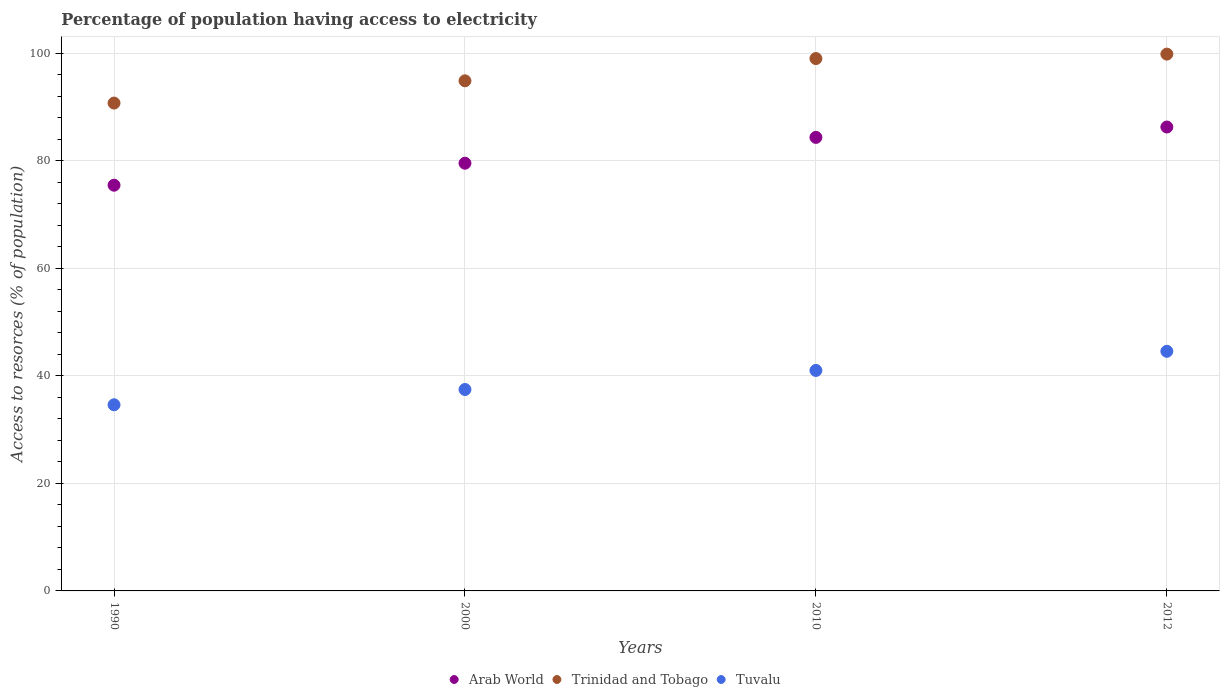How many different coloured dotlines are there?
Your answer should be very brief. 3. What is the percentage of population having access to electricity in Arab World in 2000?
Offer a terse response. 79.54. Across all years, what is the maximum percentage of population having access to electricity in Arab World?
Offer a very short reply. 86.27. Across all years, what is the minimum percentage of population having access to electricity in Trinidad and Tobago?
Make the answer very short. 90.72. In which year was the percentage of population having access to electricity in Trinidad and Tobago minimum?
Your answer should be very brief. 1990. What is the total percentage of population having access to electricity in Arab World in the graph?
Offer a terse response. 325.6. What is the difference between the percentage of population having access to electricity in Arab World in 1990 and that in 2000?
Give a very brief answer. -4.09. What is the difference between the percentage of population having access to electricity in Trinidad and Tobago in 2010 and the percentage of population having access to electricity in Tuvalu in 2012?
Ensure brevity in your answer.  54.44. What is the average percentage of population having access to electricity in Trinidad and Tobago per year?
Ensure brevity in your answer.  96.1. In how many years, is the percentage of population having access to electricity in Arab World greater than 84 %?
Keep it short and to the point. 2. What is the ratio of the percentage of population having access to electricity in Trinidad and Tobago in 2010 to that in 2012?
Keep it short and to the point. 0.99. Is the percentage of population having access to electricity in Arab World in 2010 less than that in 2012?
Ensure brevity in your answer.  Yes. What is the difference between the highest and the second highest percentage of population having access to electricity in Arab World?
Give a very brief answer. 1.93. What is the difference between the highest and the lowest percentage of population having access to electricity in Arab World?
Ensure brevity in your answer.  10.82. In how many years, is the percentage of population having access to electricity in Arab World greater than the average percentage of population having access to electricity in Arab World taken over all years?
Your answer should be compact. 2. Is it the case that in every year, the sum of the percentage of population having access to electricity in Trinidad and Tobago and percentage of population having access to electricity in Tuvalu  is greater than the percentage of population having access to electricity in Arab World?
Keep it short and to the point. Yes. Does the percentage of population having access to electricity in Arab World monotonically increase over the years?
Offer a very short reply. Yes. Is the percentage of population having access to electricity in Tuvalu strictly greater than the percentage of population having access to electricity in Arab World over the years?
Keep it short and to the point. No. Is the percentage of population having access to electricity in Tuvalu strictly less than the percentage of population having access to electricity in Arab World over the years?
Ensure brevity in your answer.  Yes. How many dotlines are there?
Ensure brevity in your answer.  3. What is the difference between two consecutive major ticks on the Y-axis?
Provide a succinct answer. 20. Are the values on the major ticks of Y-axis written in scientific E-notation?
Your response must be concise. No. Does the graph contain grids?
Provide a succinct answer. Yes. How are the legend labels stacked?
Give a very brief answer. Horizontal. What is the title of the graph?
Provide a short and direct response. Percentage of population having access to electricity. Does "Nepal" appear as one of the legend labels in the graph?
Offer a terse response. No. What is the label or title of the X-axis?
Provide a short and direct response. Years. What is the label or title of the Y-axis?
Make the answer very short. Access to resorces (% of population). What is the Access to resorces (% of population) in Arab World in 1990?
Your response must be concise. 75.45. What is the Access to resorces (% of population) of Trinidad and Tobago in 1990?
Ensure brevity in your answer.  90.72. What is the Access to resorces (% of population) of Tuvalu in 1990?
Your response must be concise. 34.62. What is the Access to resorces (% of population) of Arab World in 2000?
Offer a very short reply. 79.54. What is the Access to resorces (% of population) in Trinidad and Tobago in 2000?
Provide a succinct answer. 94.86. What is the Access to resorces (% of population) of Tuvalu in 2000?
Offer a very short reply. 37.46. What is the Access to resorces (% of population) in Arab World in 2010?
Offer a terse response. 84.34. What is the Access to resorces (% of population) in Trinidad and Tobago in 2010?
Offer a terse response. 99. What is the Access to resorces (% of population) of Tuvalu in 2010?
Keep it short and to the point. 41. What is the Access to resorces (% of population) of Arab World in 2012?
Provide a short and direct response. 86.27. What is the Access to resorces (% of population) of Trinidad and Tobago in 2012?
Your answer should be compact. 99.83. What is the Access to resorces (% of population) in Tuvalu in 2012?
Provide a short and direct response. 44.56. Across all years, what is the maximum Access to resorces (% of population) of Arab World?
Offer a terse response. 86.27. Across all years, what is the maximum Access to resorces (% of population) in Trinidad and Tobago?
Ensure brevity in your answer.  99.83. Across all years, what is the maximum Access to resorces (% of population) of Tuvalu?
Provide a succinct answer. 44.56. Across all years, what is the minimum Access to resorces (% of population) of Arab World?
Give a very brief answer. 75.45. Across all years, what is the minimum Access to resorces (% of population) in Trinidad and Tobago?
Your response must be concise. 90.72. Across all years, what is the minimum Access to resorces (% of population) of Tuvalu?
Offer a terse response. 34.62. What is the total Access to resorces (% of population) of Arab World in the graph?
Offer a very short reply. 325.6. What is the total Access to resorces (% of population) in Trinidad and Tobago in the graph?
Your response must be concise. 384.41. What is the total Access to resorces (% of population) in Tuvalu in the graph?
Provide a short and direct response. 157.63. What is the difference between the Access to resorces (% of population) in Arab World in 1990 and that in 2000?
Your answer should be very brief. -4.09. What is the difference between the Access to resorces (% of population) in Trinidad and Tobago in 1990 and that in 2000?
Offer a very short reply. -4.14. What is the difference between the Access to resorces (% of population) of Tuvalu in 1990 and that in 2000?
Your answer should be very brief. -2.84. What is the difference between the Access to resorces (% of population) in Arab World in 1990 and that in 2010?
Keep it short and to the point. -8.89. What is the difference between the Access to resorces (% of population) in Trinidad and Tobago in 1990 and that in 2010?
Offer a very short reply. -8.28. What is the difference between the Access to resorces (% of population) of Tuvalu in 1990 and that in 2010?
Keep it short and to the point. -6.38. What is the difference between the Access to resorces (% of population) of Arab World in 1990 and that in 2012?
Keep it short and to the point. -10.82. What is the difference between the Access to resorces (% of population) of Trinidad and Tobago in 1990 and that in 2012?
Make the answer very short. -9.11. What is the difference between the Access to resorces (% of population) of Tuvalu in 1990 and that in 2012?
Your answer should be very brief. -9.95. What is the difference between the Access to resorces (% of population) of Arab World in 2000 and that in 2010?
Keep it short and to the point. -4.81. What is the difference between the Access to resorces (% of population) of Trinidad and Tobago in 2000 and that in 2010?
Your response must be concise. -4.14. What is the difference between the Access to resorces (% of population) in Tuvalu in 2000 and that in 2010?
Your response must be concise. -3.54. What is the difference between the Access to resorces (% of population) in Arab World in 2000 and that in 2012?
Your response must be concise. -6.73. What is the difference between the Access to resorces (% of population) in Trinidad and Tobago in 2000 and that in 2012?
Ensure brevity in your answer.  -4.97. What is the difference between the Access to resorces (% of population) of Tuvalu in 2000 and that in 2012?
Your answer should be very brief. -7.11. What is the difference between the Access to resorces (% of population) in Arab World in 2010 and that in 2012?
Your response must be concise. -1.93. What is the difference between the Access to resorces (% of population) in Trinidad and Tobago in 2010 and that in 2012?
Keep it short and to the point. -0.83. What is the difference between the Access to resorces (% of population) in Tuvalu in 2010 and that in 2012?
Offer a terse response. -3.56. What is the difference between the Access to resorces (% of population) of Arab World in 1990 and the Access to resorces (% of population) of Trinidad and Tobago in 2000?
Your answer should be very brief. -19.41. What is the difference between the Access to resorces (% of population) of Arab World in 1990 and the Access to resorces (% of population) of Tuvalu in 2000?
Make the answer very short. 37.99. What is the difference between the Access to resorces (% of population) of Trinidad and Tobago in 1990 and the Access to resorces (% of population) of Tuvalu in 2000?
Your answer should be compact. 53.27. What is the difference between the Access to resorces (% of population) in Arab World in 1990 and the Access to resorces (% of population) in Trinidad and Tobago in 2010?
Offer a very short reply. -23.55. What is the difference between the Access to resorces (% of population) of Arab World in 1990 and the Access to resorces (% of population) of Tuvalu in 2010?
Your answer should be compact. 34.45. What is the difference between the Access to resorces (% of population) in Trinidad and Tobago in 1990 and the Access to resorces (% of population) in Tuvalu in 2010?
Make the answer very short. 49.72. What is the difference between the Access to resorces (% of population) in Arab World in 1990 and the Access to resorces (% of population) in Trinidad and Tobago in 2012?
Offer a very short reply. -24.38. What is the difference between the Access to resorces (% of population) in Arab World in 1990 and the Access to resorces (% of population) in Tuvalu in 2012?
Offer a terse response. 30.88. What is the difference between the Access to resorces (% of population) of Trinidad and Tobago in 1990 and the Access to resorces (% of population) of Tuvalu in 2012?
Provide a succinct answer. 46.16. What is the difference between the Access to resorces (% of population) in Arab World in 2000 and the Access to resorces (% of population) in Trinidad and Tobago in 2010?
Make the answer very short. -19.46. What is the difference between the Access to resorces (% of population) in Arab World in 2000 and the Access to resorces (% of population) in Tuvalu in 2010?
Ensure brevity in your answer.  38.54. What is the difference between the Access to resorces (% of population) in Trinidad and Tobago in 2000 and the Access to resorces (% of population) in Tuvalu in 2010?
Make the answer very short. 53.86. What is the difference between the Access to resorces (% of population) in Arab World in 2000 and the Access to resorces (% of population) in Trinidad and Tobago in 2012?
Your answer should be compact. -20.29. What is the difference between the Access to resorces (% of population) of Arab World in 2000 and the Access to resorces (% of population) of Tuvalu in 2012?
Keep it short and to the point. 34.97. What is the difference between the Access to resorces (% of population) of Trinidad and Tobago in 2000 and the Access to resorces (% of population) of Tuvalu in 2012?
Offer a terse response. 50.3. What is the difference between the Access to resorces (% of population) in Arab World in 2010 and the Access to resorces (% of population) in Trinidad and Tobago in 2012?
Ensure brevity in your answer.  -15.49. What is the difference between the Access to resorces (% of population) of Arab World in 2010 and the Access to resorces (% of population) of Tuvalu in 2012?
Your answer should be very brief. 39.78. What is the difference between the Access to resorces (% of population) of Trinidad and Tobago in 2010 and the Access to resorces (% of population) of Tuvalu in 2012?
Provide a succinct answer. 54.44. What is the average Access to resorces (% of population) in Arab World per year?
Your response must be concise. 81.4. What is the average Access to resorces (% of population) of Trinidad and Tobago per year?
Your answer should be compact. 96.1. What is the average Access to resorces (% of population) of Tuvalu per year?
Ensure brevity in your answer.  39.41. In the year 1990, what is the difference between the Access to resorces (% of population) in Arab World and Access to resorces (% of population) in Trinidad and Tobago?
Offer a terse response. -15.27. In the year 1990, what is the difference between the Access to resorces (% of population) in Arab World and Access to resorces (% of population) in Tuvalu?
Make the answer very short. 40.83. In the year 1990, what is the difference between the Access to resorces (% of population) of Trinidad and Tobago and Access to resorces (% of population) of Tuvalu?
Make the answer very short. 56.11. In the year 2000, what is the difference between the Access to resorces (% of population) of Arab World and Access to resorces (% of population) of Trinidad and Tobago?
Your answer should be very brief. -15.32. In the year 2000, what is the difference between the Access to resorces (% of population) of Arab World and Access to resorces (% of population) of Tuvalu?
Your response must be concise. 42.08. In the year 2000, what is the difference between the Access to resorces (% of population) in Trinidad and Tobago and Access to resorces (% of population) in Tuvalu?
Your answer should be very brief. 57.41. In the year 2010, what is the difference between the Access to resorces (% of population) in Arab World and Access to resorces (% of population) in Trinidad and Tobago?
Your answer should be compact. -14.66. In the year 2010, what is the difference between the Access to resorces (% of population) of Arab World and Access to resorces (% of population) of Tuvalu?
Offer a very short reply. 43.34. In the year 2010, what is the difference between the Access to resorces (% of population) in Trinidad and Tobago and Access to resorces (% of population) in Tuvalu?
Your response must be concise. 58. In the year 2012, what is the difference between the Access to resorces (% of population) in Arab World and Access to resorces (% of population) in Trinidad and Tobago?
Provide a succinct answer. -13.56. In the year 2012, what is the difference between the Access to resorces (% of population) in Arab World and Access to resorces (% of population) in Tuvalu?
Your answer should be compact. 41.71. In the year 2012, what is the difference between the Access to resorces (% of population) of Trinidad and Tobago and Access to resorces (% of population) of Tuvalu?
Your answer should be very brief. 55.27. What is the ratio of the Access to resorces (% of population) in Arab World in 1990 to that in 2000?
Your response must be concise. 0.95. What is the ratio of the Access to resorces (% of population) of Trinidad and Tobago in 1990 to that in 2000?
Your answer should be very brief. 0.96. What is the ratio of the Access to resorces (% of population) in Tuvalu in 1990 to that in 2000?
Your answer should be compact. 0.92. What is the ratio of the Access to resorces (% of population) of Arab World in 1990 to that in 2010?
Offer a terse response. 0.89. What is the ratio of the Access to resorces (% of population) in Trinidad and Tobago in 1990 to that in 2010?
Provide a succinct answer. 0.92. What is the ratio of the Access to resorces (% of population) in Tuvalu in 1990 to that in 2010?
Provide a short and direct response. 0.84. What is the ratio of the Access to resorces (% of population) of Arab World in 1990 to that in 2012?
Ensure brevity in your answer.  0.87. What is the ratio of the Access to resorces (% of population) in Trinidad and Tobago in 1990 to that in 2012?
Give a very brief answer. 0.91. What is the ratio of the Access to resorces (% of population) in Tuvalu in 1990 to that in 2012?
Offer a terse response. 0.78. What is the ratio of the Access to resorces (% of population) in Arab World in 2000 to that in 2010?
Give a very brief answer. 0.94. What is the ratio of the Access to resorces (% of population) of Trinidad and Tobago in 2000 to that in 2010?
Your answer should be compact. 0.96. What is the ratio of the Access to resorces (% of population) of Tuvalu in 2000 to that in 2010?
Keep it short and to the point. 0.91. What is the ratio of the Access to resorces (% of population) in Arab World in 2000 to that in 2012?
Your answer should be very brief. 0.92. What is the ratio of the Access to resorces (% of population) in Trinidad and Tobago in 2000 to that in 2012?
Your response must be concise. 0.95. What is the ratio of the Access to resorces (% of population) of Tuvalu in 2000 to that in 2012?
Offer a terse response. 0.84. What is the ratio of the Access to resorces (% of population) in Arab World in 2010 to that in 2012?
Keep it short and to the point. 0.98. What is the ratio of the Access to resorces (% of population) in Tuvalu in 2010 to that in 2012?
Ensure brevity in your answer.  0.92. What is the difference between the highest and the second highest Access to resorces (% of population) of Arab World?
Ensure brevity in your answer.  1.93. What is the difference between the highest and the second highest Access to resorces (% of population) of Trinidad and Tobago?
Give a very brief answer. 0.83. What is the difference between the highest and the second highest Access to resorces (% of population) of Tuvalu?
Give a very brief answer. 3.56. What is the difference between the highest and the lowest Access to resorces (% of population) of Arab World?
Your response must be concise. 10.82. What is the difference between the highest and the lowest Access to resorces (% of population) of Trinidad and Tobago?
Keep it short and to the point. 9.11. What is the difference between the highest and the lowest Access to resorces (% of population) in Tuvalu?
Your answer should be compact. 9.95. 